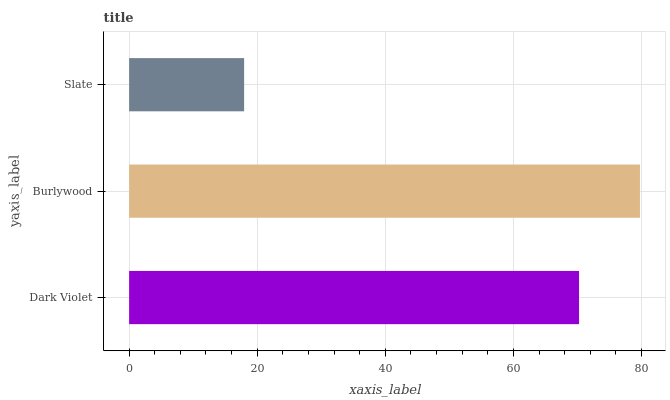Is Slate the minimum?
Answer yes or no. Yes. Is Burlywood the maximum?
Answer yes or no. Yes. Is Burlywood the minimum?
Answer yes or no. No. Is Slate the maximum?
Answer yes or no. No. Is Burlywood greater than Slate?
Answer yes or no. Yes. Is Slate less than Burlywood?
Answer yes or no. Yes. Is Slate greater than Burlywood?
Answer yes or no. No. Is Burlywood less than Slate?
Answer yes or no. No. Is Dark Violet the high median?
Answer yes or no. Yes. Is Dark Violet the low median?
Answer yes or no. Yes. Is Slate the high median?
Answer yes or no. No. Is Burlywood the low median?
Answer yes or no. No. 